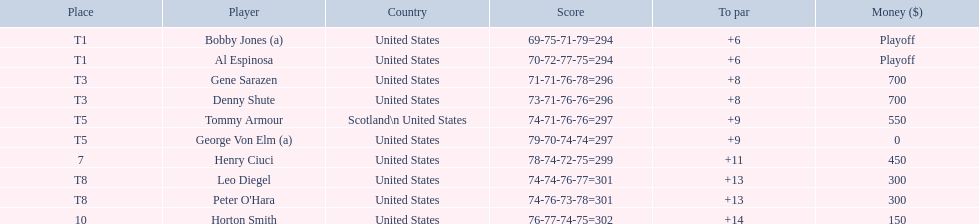Did tommy armour rank higher or lower than denny shute? Below. 